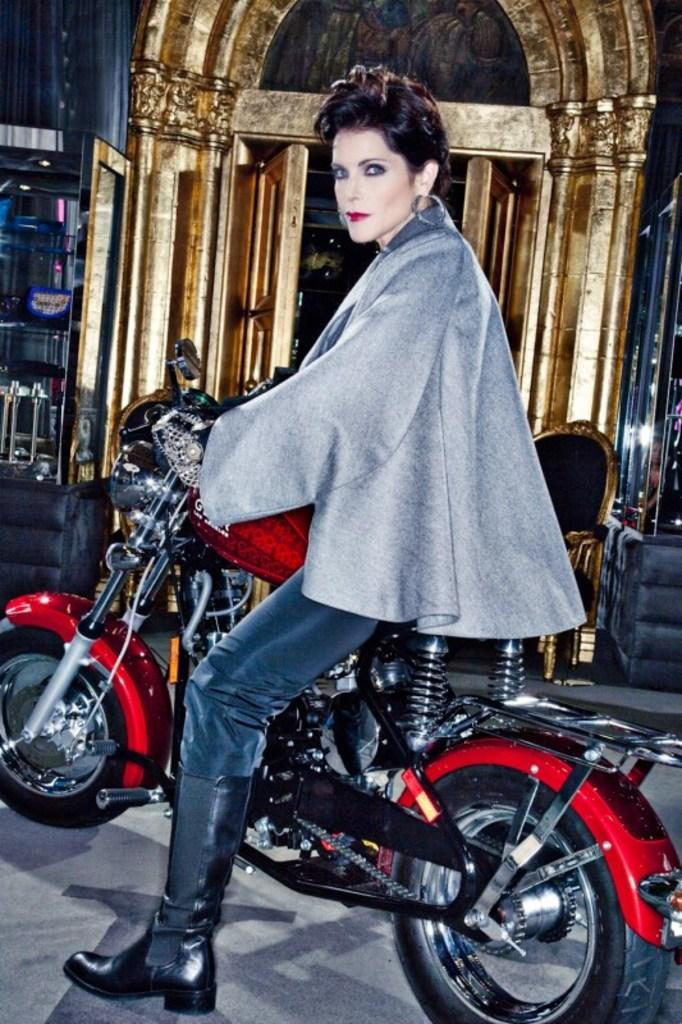Who is present in the image? There is a woman in the image. What is the woman doing in the image? The woman is sitting on a motorcycle. What type of fruit is hanging from the side of the motorcycle in the image? There is no fruit present in the image, and no fruit is hanging from the side of the motorcycle. 